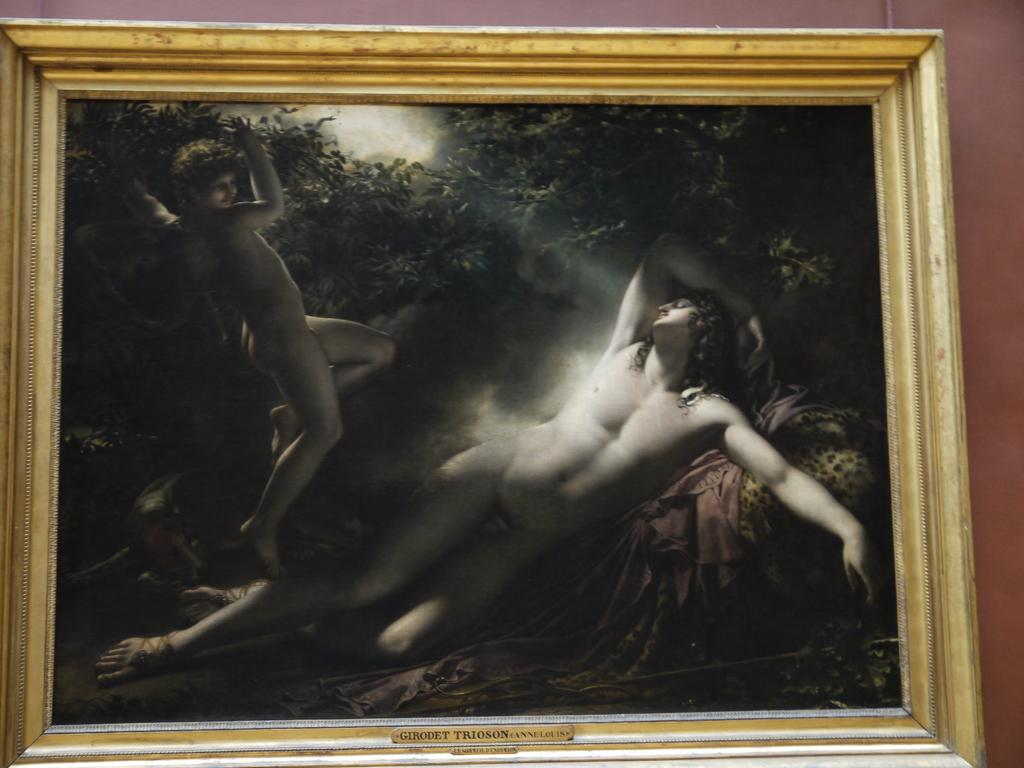What is attached to the wall in the image? There is a frame attached to the wall in the image. What is inside the frame? The frame contains a picture of two persons. What can be seen in the background of the picture within the frame? There are trees visible in the picture within the frame. What type of hen can be seen sitting on the cable in the image? There is no hen or cable present in the image. How is the wax used in the image? There is no wax present in the image. 